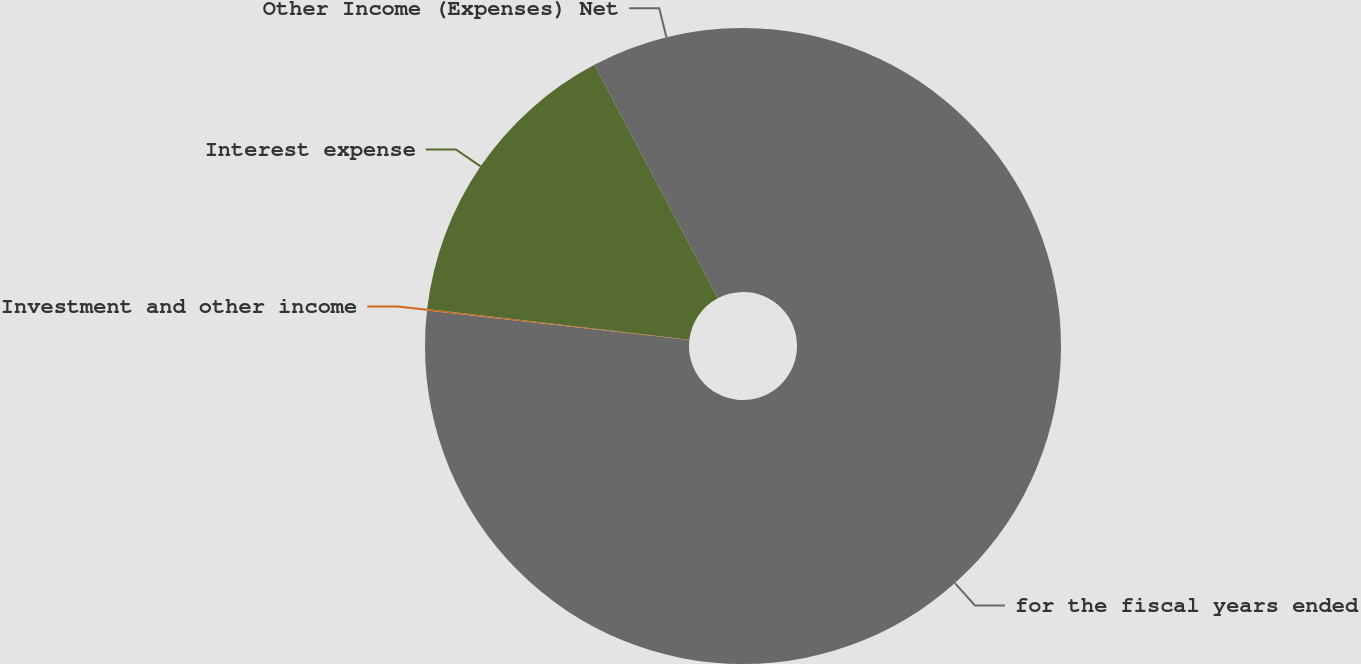Convert chart. <chart><loc_0><loc_0><loc_500><loc_500><pie_chart><fcel>for the fiscal years ended<fcel>Investment and other income<fcel>Interest expense<fcel>Other Income (Expenses) Net<nl><fcel>76.78%<fcel>0.07%<fcel>15.41%<fcel>7.74%<nl></chart> 